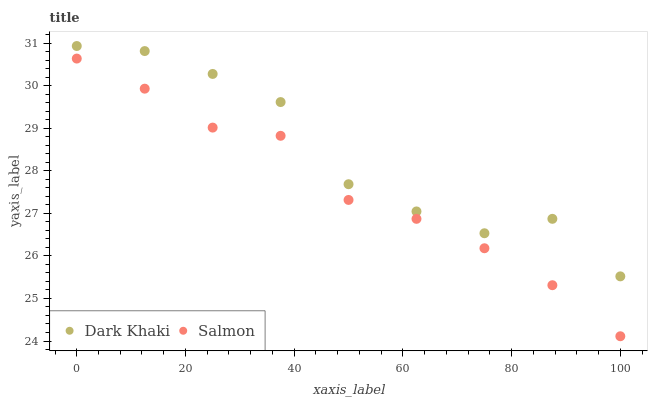Does Salmon have the minimum area under the curve?
Answer yes or no. Yes. Does Dark Khaki have the maximum area under the curve?
Answer yes or no. Yes. Does Salmon have the maximum area under the curve?
Answer yes or no. No. Is Salmon the smoothest?
Answer yes or no. Yes. Is Dark Khaki the roughest?
Answer yes or no. Yes. Is Salmon the roughest?
Answer yes or no. No. Does Salmon have the lowest value?
Answer yes or no. Yes. Does Dark Khaki have the highest value?
Answer yes or no. Yes. Does Salmon have the highest value?
Answer yes or no. No. Is Salmon less than Dark Khaki?
Answer yes or no. Yes. Is Dark Khaki greater than Salmon?
Answer yes or no. Yes. Does Salmon intersect Dark Khaki?
Answer yes or no. No. 